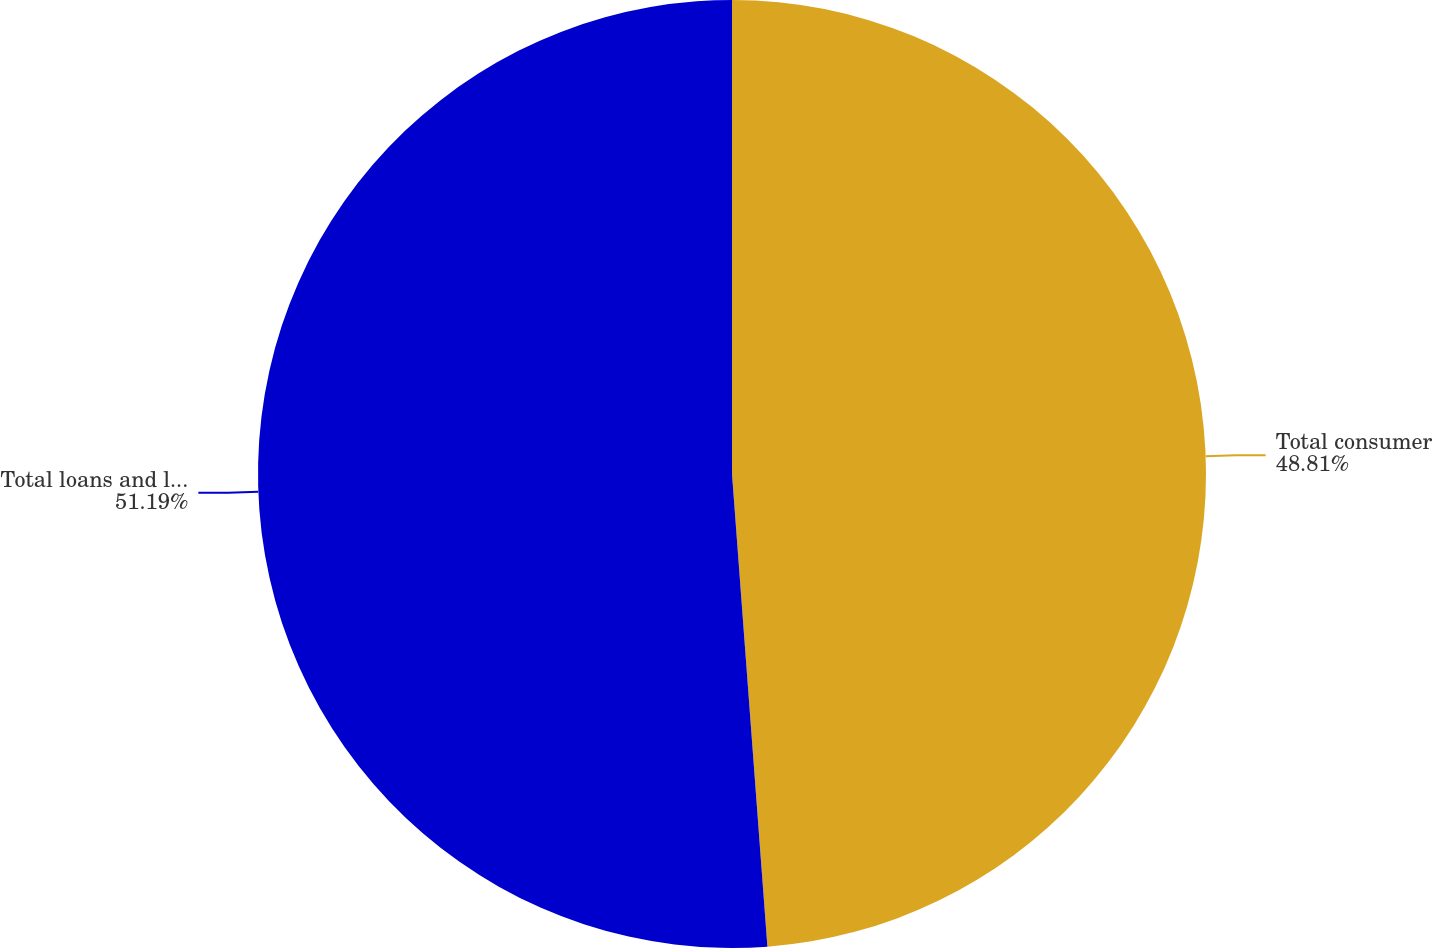Convert chart. <chart><loc_0><loc_0><loc_500><loc_500><pie_chart><fcel>Total consumer<fcel>Total loans and leases<nl><fcel>48.81%<fcel>51.19%<nl></chart> 